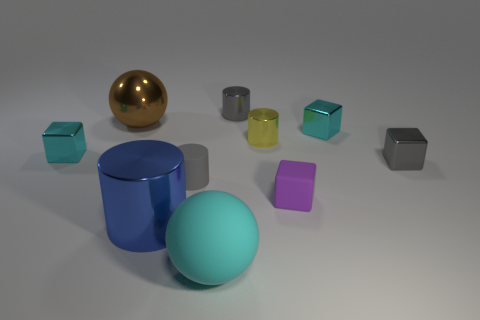Subtract 1 cylinders. How many cylinders are left? 3 Subtract all gray cubes. How many cubes are left? 3 Subtract all red cylinders. Subtract all blue balls. How many cylinders are left? 4 Subtract all cylinders. How many objects are left? 6 Add 1 metallic balls. How many metallic balls are left? 2 Add 5 large red shiny spheres. How many large red shiny spheres exist? 5 Subtract 0 yellow balls. How many objects are left? 10 Subtract all brown balls. Subtract all small yellow cylinders. How many objects are left? 8 